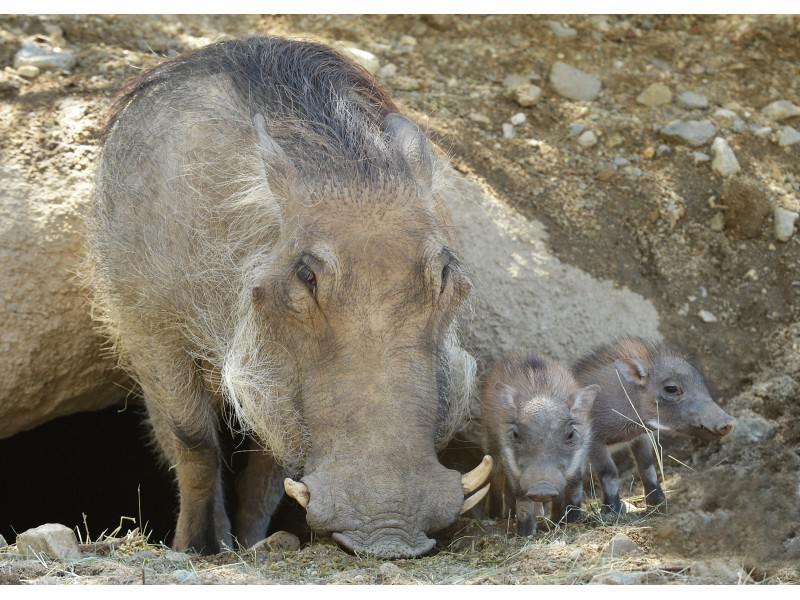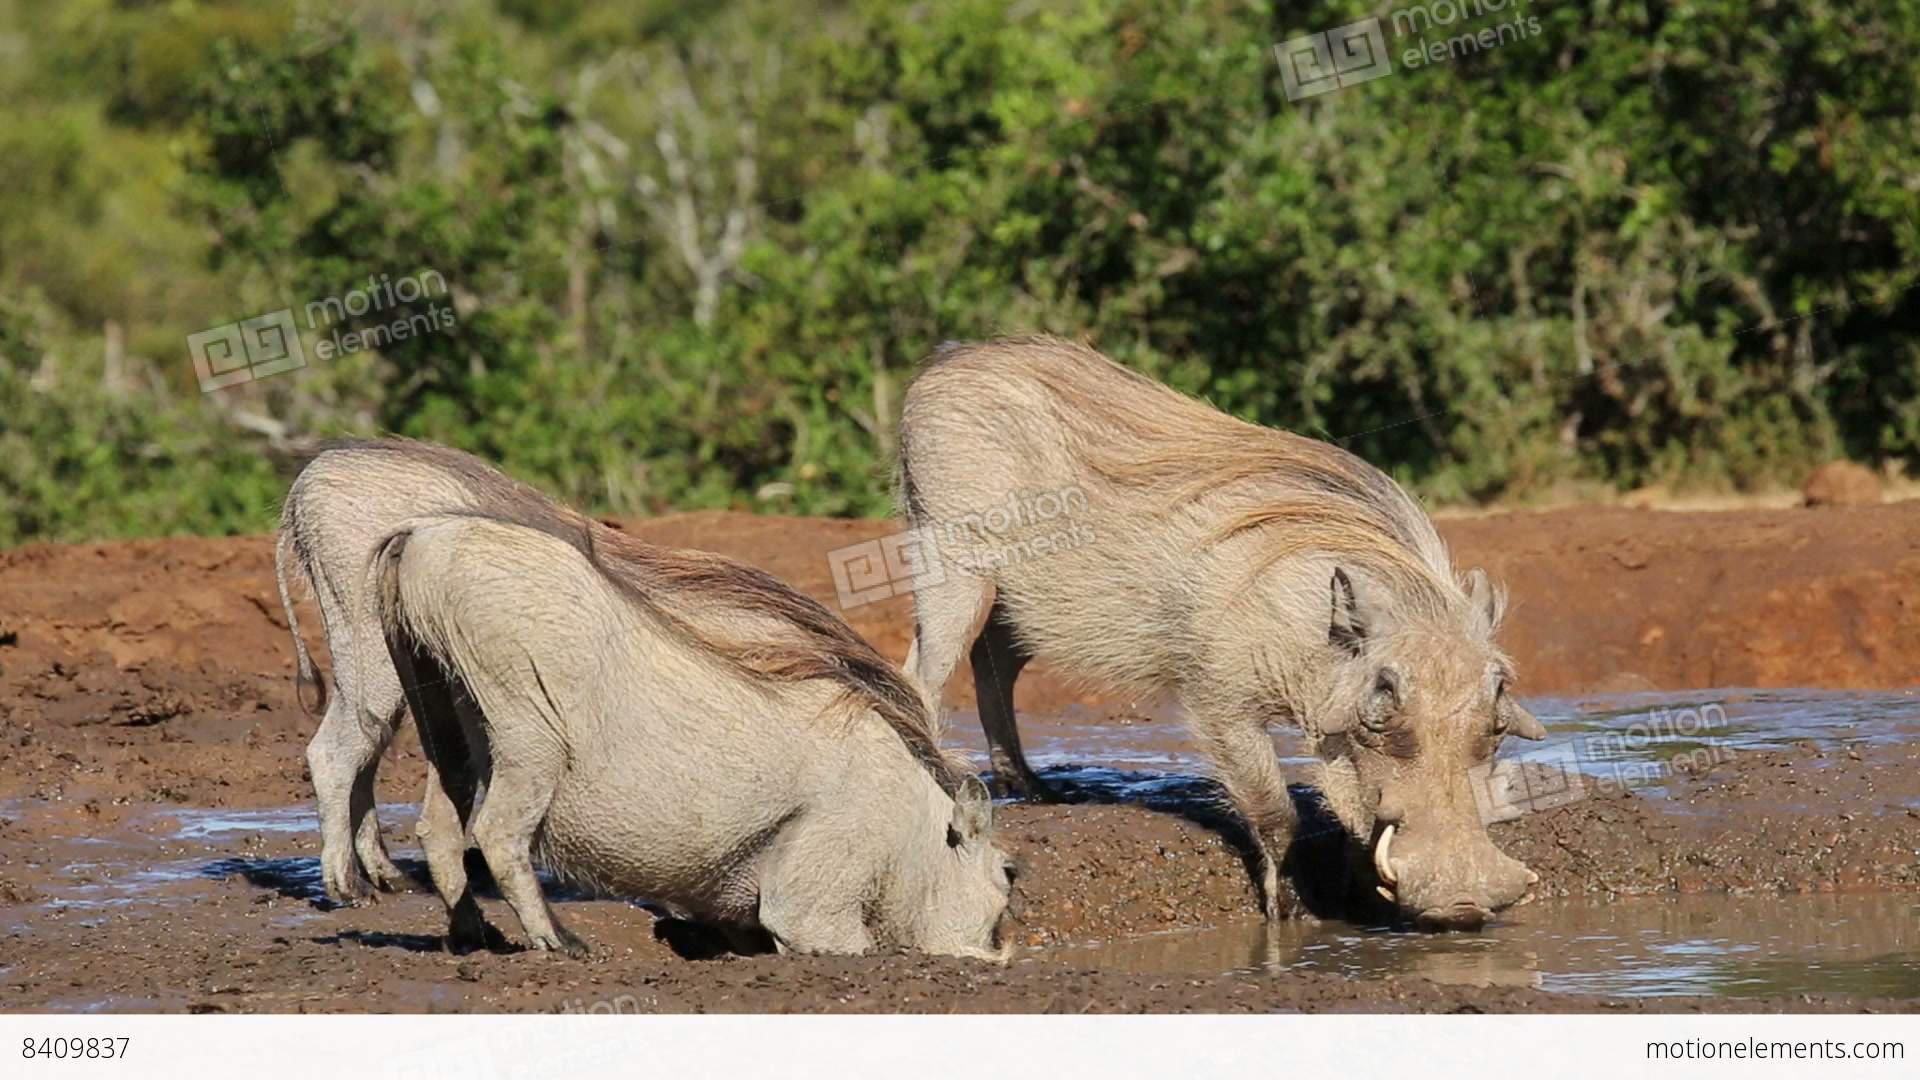The first image is the image on the left, the second image is the image on the right. Evaluate the accuracy of this statement regarding the images: "The combined images show four warthogs and do not show any other mammal.". Is it true? Answer yes or no. No. The first image is the image on the left, the second image is the image on the right. Given the left and right images, does the statement "A hog and two baby hogs are grazing in the left picture." hold true? Answer yes or no. Yes. 